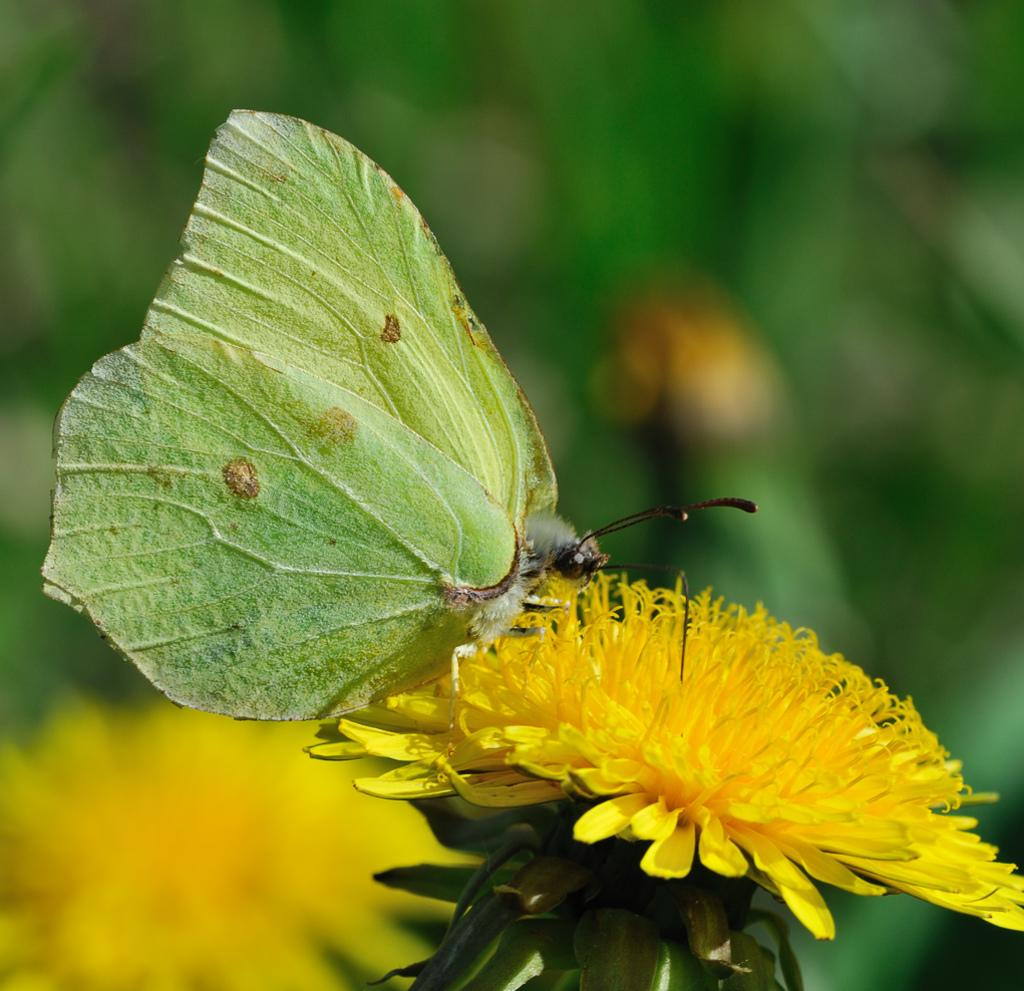What is the main subject of the image? There is a butterfly in the image. Where is the butterfly located? The butterfly is on a flower. How is the image composed in terms of focus? The foreground area of the image is in focus, while the background is blurry. What type of notebook can be seen in the hair of the giant in the image? There are no giants or notebooks present in the image; it features a butterfly on a flower. 